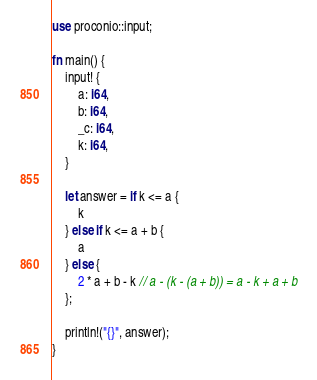<code> <loc_0><loc_0><loc_500><loc_500><_Rust_>use proconio::input;

fn main() {
    input! {
        a: i64,
        b: i64,
        _c: i64,
        k: i64,
    }

    let answer = if k <= a {
        k
    } else if k <= a + b {
        a
    } else {
        2 * a + b - k // a - (k - (a + b)) = a - k + a + b
    };

    println!("{}", answer);
}
</code> 